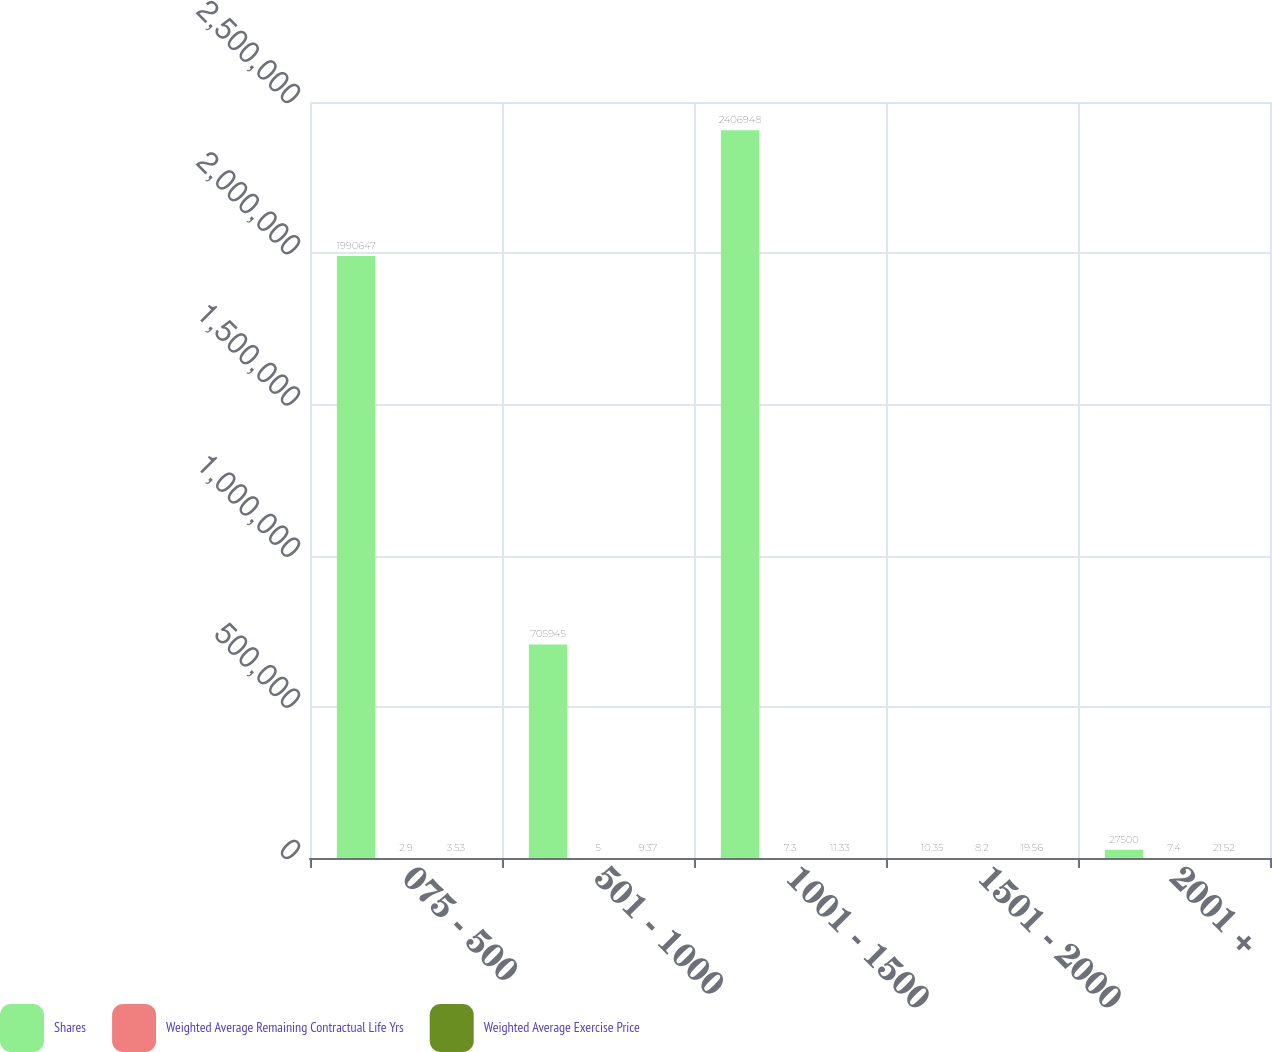Convert chart. <chart><loc_0><loc_0><loc_500><loc_500><stacked_bar_chart><ecel><fcel>075 - 500<fcel>501 - 1000<fcel>1001 - 1500<fcel>1501 - 2000<fcel>2001 +<nl><fcel>Shares<fcel>1.99065e+06<fcel>705945<fcel>2.40695e+06<fcel>10.35<fcel>27500<nl><fcel>Weighted Average Remaining Contractual Life Yrs<fcel>2.9<fcel>5<fcel>7.3<fcel>8.2<fcel>7.4<nl><fcel>Weighted Average Exercise Price<fcel>3.53<fcel>9.37<fcel>11.33<fcel>19.56<fcel>21.52<nl></chart> 